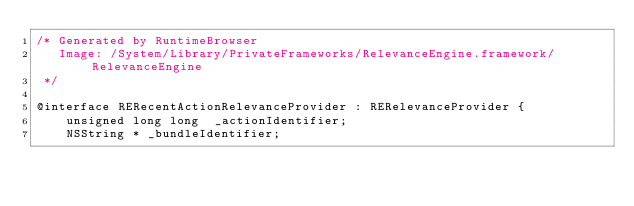<code> <loc_0><loc_0><loc_500><loc_500><_C_>/* Generated by RuntimeBrowser
   Image: /System/Library/PrivateFrameworks/RelevanceEngine.framework/RelevanceEngine
 */

@interface RERecentActionRelevanceProvider : RERelevanceProvider {
    unsigned long long  _actionIdentifier;
    NSString * _bundleIdentifier;</code> 